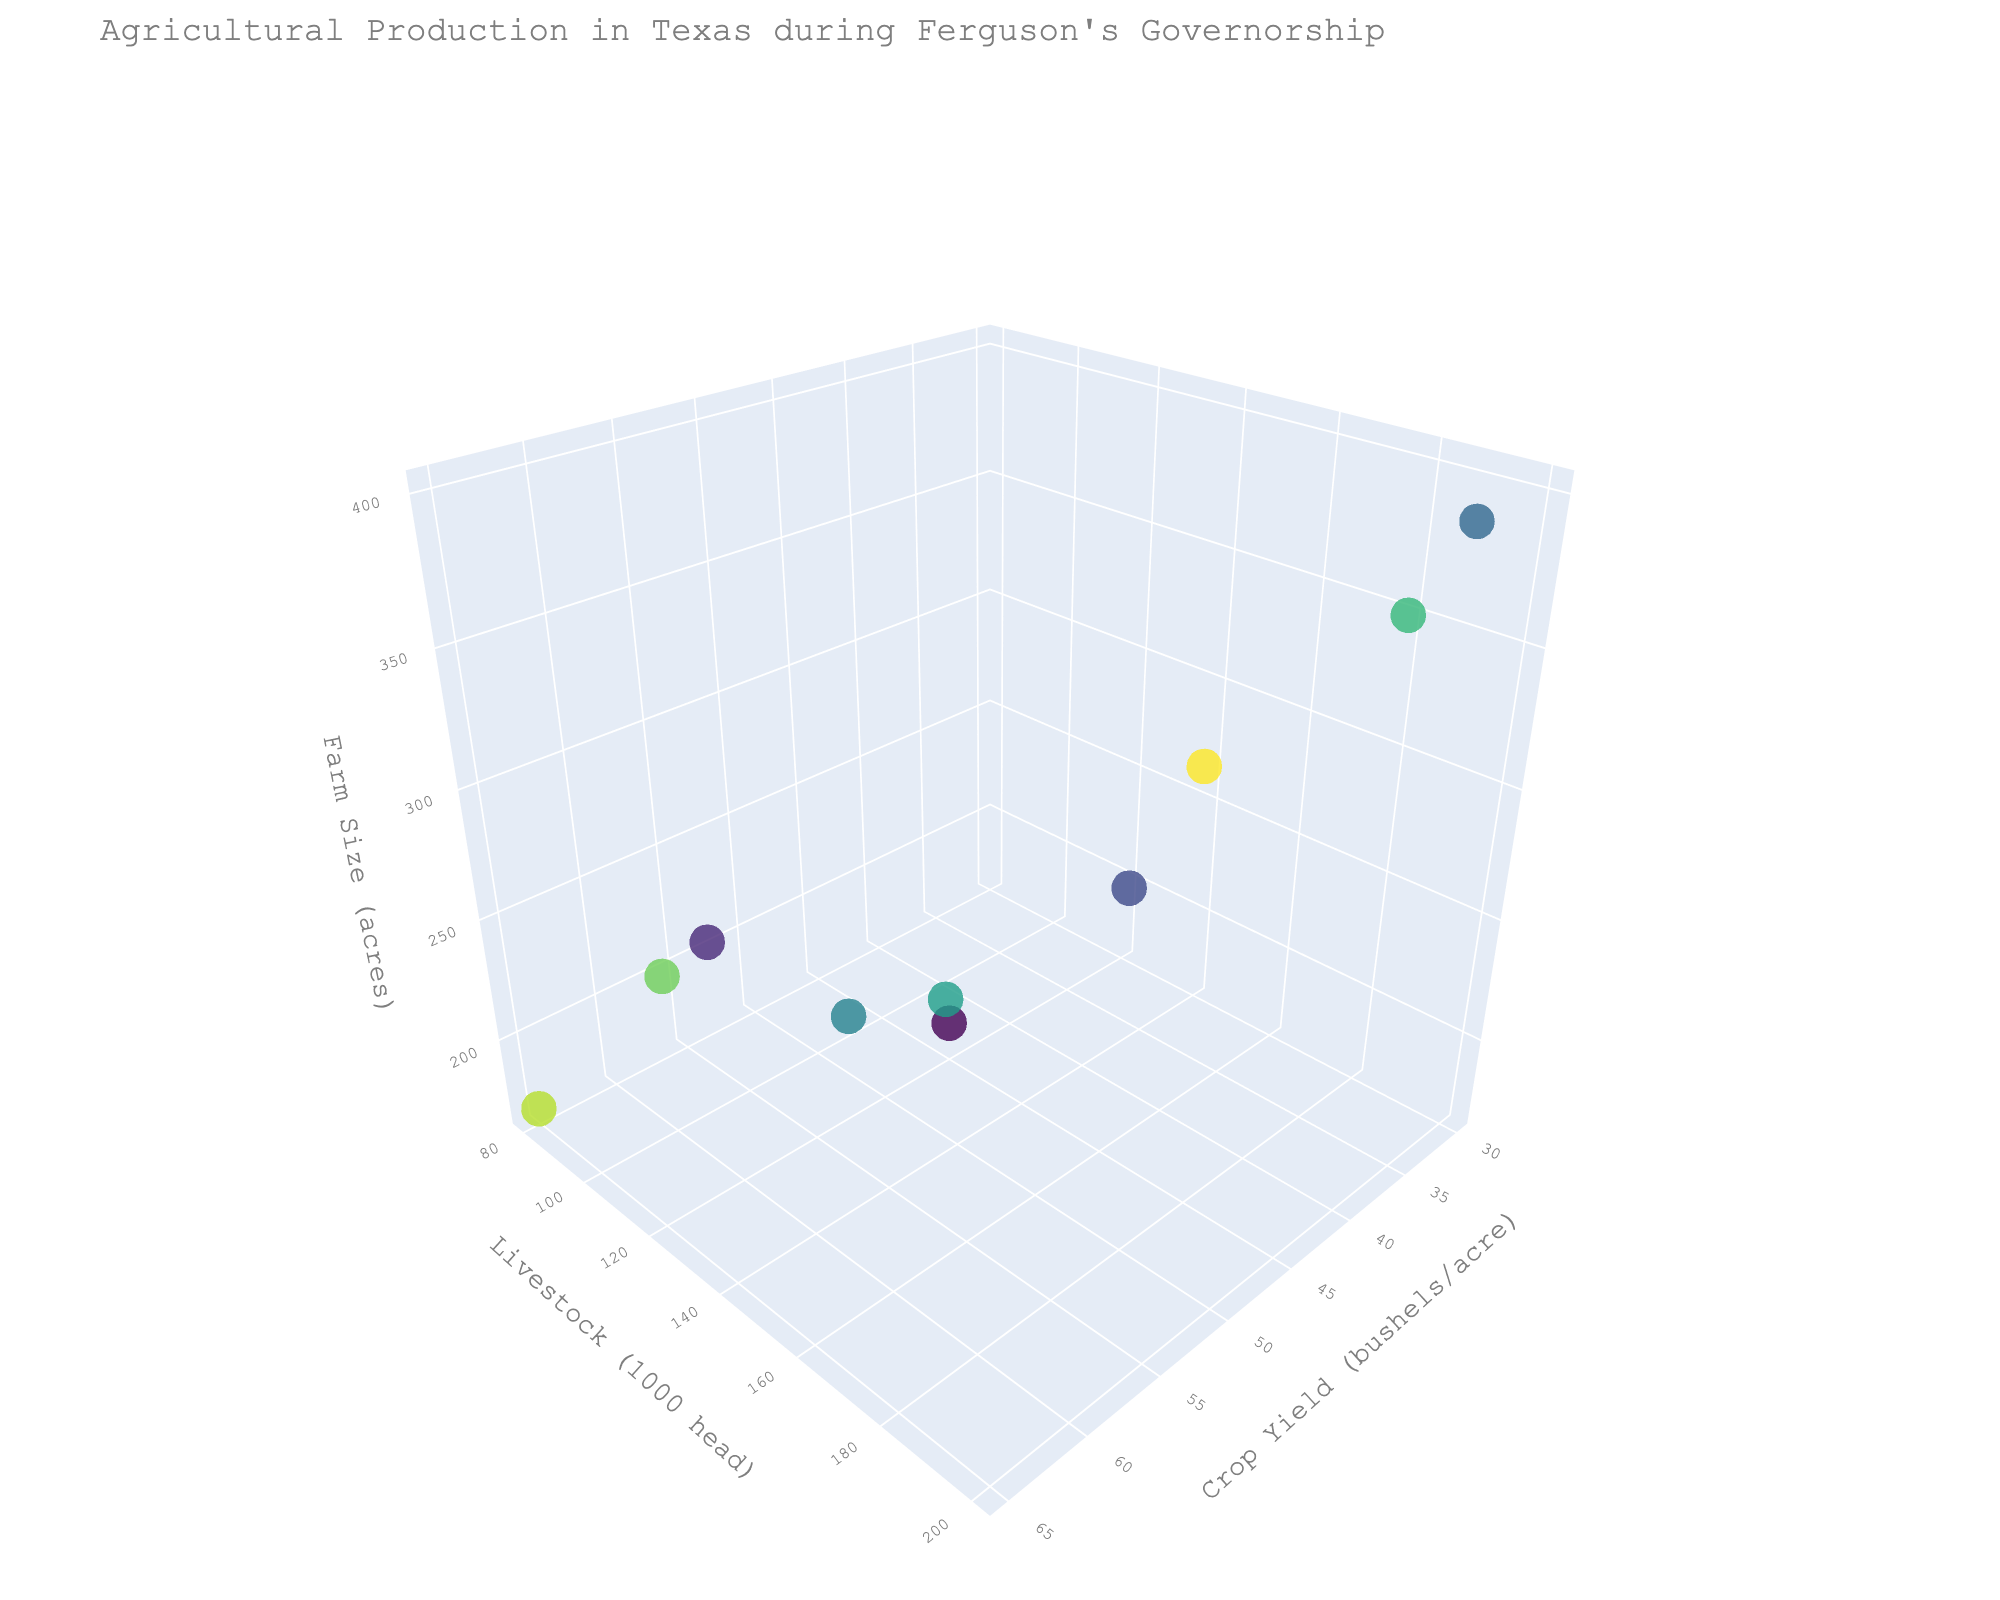What's the title of the figure? The title is usually displayed at the top of the figure. It summarizes the content of the plot.
Answer: Agricultural Production in Texas during Ferguson's Governorship What are the three axes labeled in the figure? The axes labels are directly shown alongside the axes which represent different dimensions of data.
Answer: Crop Yield (bushels/acre), Livestock (1000 head), Farm Size (acres) How many regions are represented in the figure? Each marker in the 3D scatter plot represents a region and corresponds to an entry in the data. Counting them gives the number of regions.
Answer: 10 Which region has the highest crop yield? The region with the highest crop yield will have the marker furthest along the Crop Yield (bushels/acre) axis.
Answer: Rio Grande Valley Which region has the largest farm size? The region with the largest farm size will have the marker with the highest value along the Farm Size (acres) axis.
Answer: Panhandle Which region has the most livestock? The region with the most livestock is identified by finding the marker with the highest value along the Livestock (1000 head) axis.
Answer: Panhandle What is the sum of the farm sizes of Gulf Coast and Central Texas? Locate the markers for Gulf Coast and Central Texas, read their farm sizes, and add them. Gulf Coast's size is 220 and Central Texas's size is 210.
Answer: 430 Compare the crop yields between East Texas and Blackland Prairie. Which one is greater? Locate the markers for East Texas and Blackland Prairie, and compare their positions along the Crop Yield (bushels/acre) axis. Blackland Prairie has a higher crop yield.
Answer: Blackland Prairie What is the difference in livestock numbers between North Texas and Rio Grande Valley? Find the markers for North Texas and Rio Grande Valley, read their values on the Livestock (1000 head) axis, and subtract the smaller from the larger. North Texas has 150 and Rio Grande Valley has 80.
Answer: 70 What region has a high crop yield but lower livestock numbers compared to other regions? Identify the marker with a high value on the Crop Yield (bushels/acre) axis but relatively low on the Livestock (1000 head) axis.
Answer: Rio Grande Valley 